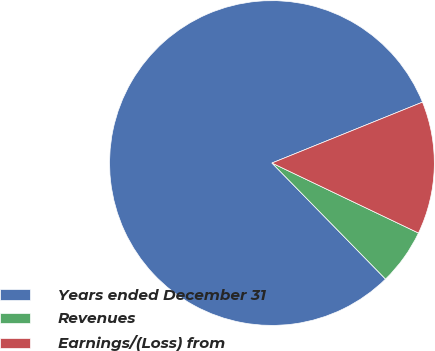Convert chart. <chart><loc_0><loc_0><loc_500><loc_500><pie_chart><fcel>Years ended December 31<fcel>Revenues<fcel>Earnings/(Loss) from<nl><fcel>81.21%<fcel>5.58%<fcel>13.21%<nl></chart> 